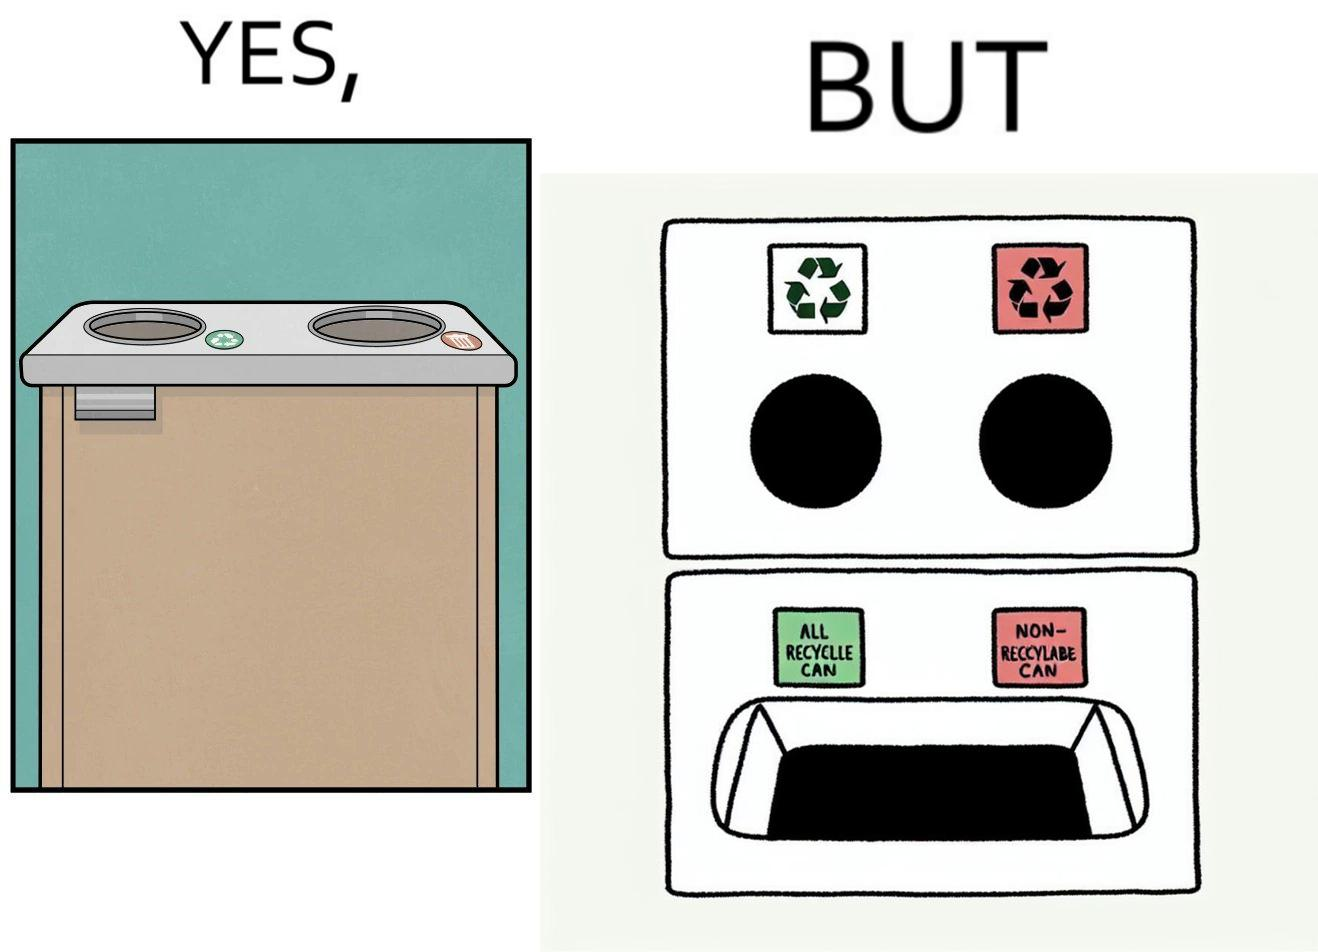Explain why this image is satirical. The image is funny because while there are different holes provided to dump different kinds of waste, the separation is meaningless because the underlying bin which is the same. So all kinds of trash is collected together and can not be used for recycling. 